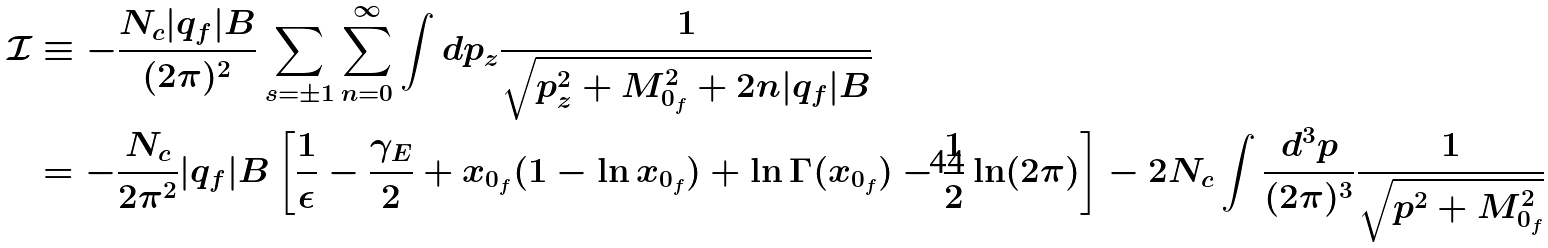<formula> <loc_0><loc_0><loc_500><loc_500>\mathcal { I } & \equiv - \frac { N _ { c } | q _ { f } | B } { ( 2 \pi ) ^ { 2 } } \sum _ { s = \pm 1 } \sum _ { n = 0 } ^ { \infty } \int d p _ { z } \frac { 1 } { \sqrt { p _ { z } ^ { 2 } + M _ { 0 _ { f } } ^ { 2 } + 2 n | q _ { f } | B } } \\ & = - \frac { N _ { c } } { 2 \pi ^ { 2 } } | q _ { f } | B \left [ \frac { 1 } { \epsilon } - \frac { \gamma _ { E } } { 2 } + x _ { 0 _ { f } } ( 1 - \ln x _ { 0 _ { f } } ) + \ln \Gamma ( x _ { 0 _ { f } } ) - \frac { 1 } { 2 } \ln ( 2 \pi ) \right ] - 2 N _ { c } \int \frac { d ^ { 3 } p } { ( 2 \pi ) ^ { 3 } } \frac { 1 } { \sqrt { p ^ { 2 } + M _ { 0 _ { f } } ^ { 2 } } }</formula> 